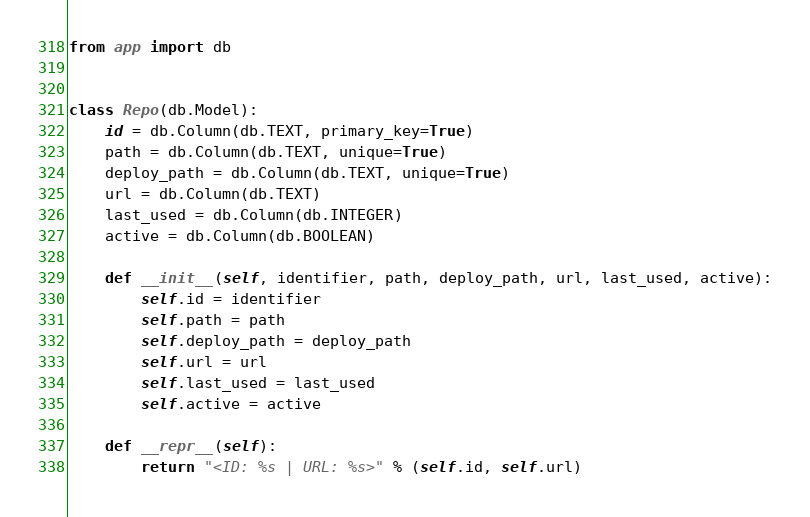<code> <loc_0><loc_0><loc_500><loc_500><_Python_>from app import db


class Repo(db.Model):
    id = db.Column(db.TEXT, primary_key=True)
    path = db.Column(db.TEXT, unique=True)
    deploy_path = db.Column(db.TEXT, unique=True)
    url = db.Column(db.TEXT)
    last_used = db.Column(db.INTEGER)
    active = db.Column(db.BOOLEAN)

    def __init__(self, identifier, path, deploy_path, url, last_used, active):
        self.id = identifier
        self.path = path
        self.deploy_path = deploy_path
        self.url = url
        self.last_used = last_used
        self.active = active

    def __repr__(self):
        return "<ID: %s | URL: %s>" % (self.id, self.url)
</code> 